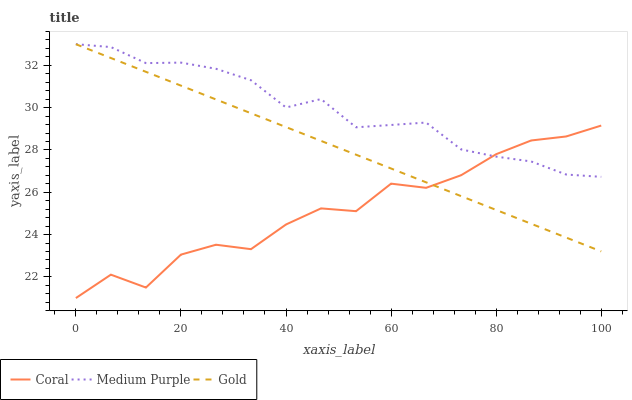Does Coral have the minimum area under the curve?
Answer yes or no. Yes. Does Medium Purple have the maximum area under the curve?
Answer yes or no. Yes. Does Gold have the minimum area under the curve?
Answer yes or no. No. Does Gold have the maximum area under the curve?
Answer yes or no. No. Is Gold the smoothest?
Answer yes or no. Yes. Is Coral the roughest?
Answer yes or no. Yes. Is Coral the smoothest?
Answer yes or no. No. Is Gold the roughest?
Answer yes or no. No. Does Coral have the lowest value?
Answer yes or no. Yes. Does Gold have the lowest value?
Answer yes or no. No. Does Gold have the highest value?
Answer yes or no. Yes. Does Coral have the highest value?
Answer yes or no. No. Does Gold intersect Coral?
Answer yes or no. Yes. Is Gold less than Coral?
Answer yes or no. No. Is Gold greater than Coral?
Answer yes or no. No. 